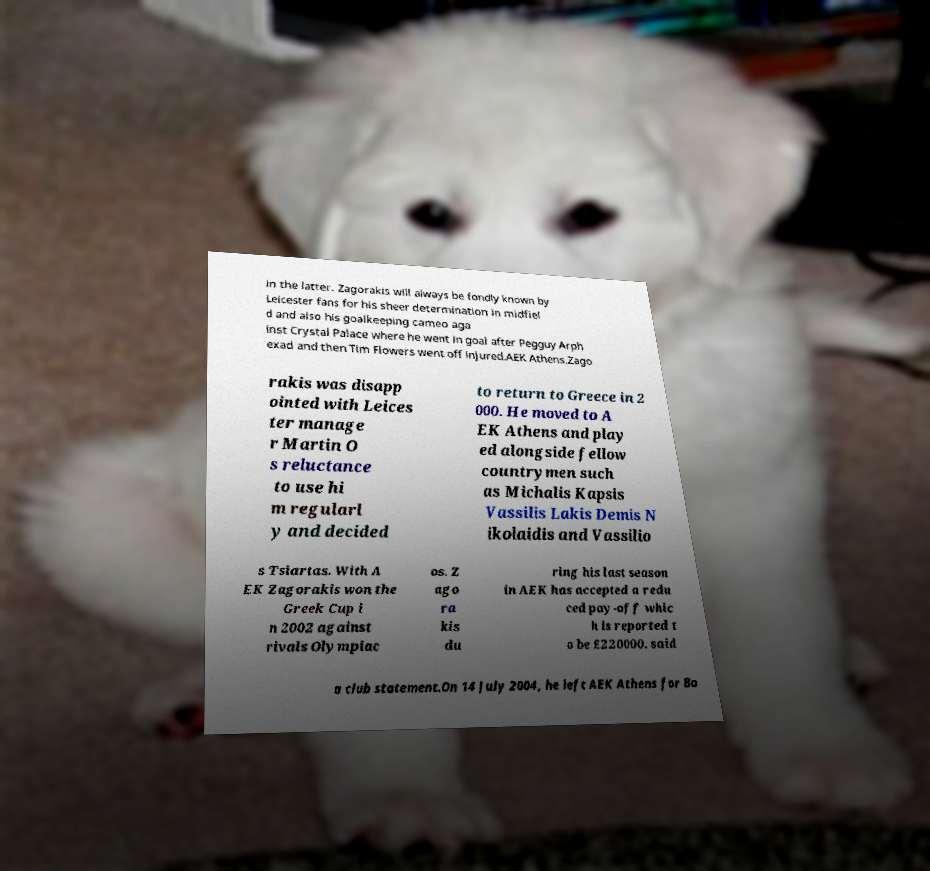Could you extract and type out the text from this image? in the latter. Zagorakis will always be fondly known by Leicester fans for his sheer determination in midfiel d and also his goalkeeping cameo aga inst Crystal Palace where he went in goal after Pegguy Arph exad and then Tim Flowers went off injured.AEK Athens.Zago rakis was disapp ointed with Leices ter manage r Martin O s reluctance to use hi m regularl y and decided to return to Greece in 2 000. He moved to A EK Athens and play ed alongside fellow countrymen such as Michalis Kapsis Vassilis Lakis Demis N ikolaidis and Vassilio s Tsiartas. With A EK Zagorakis won the Greek Cup i n 2002 against rivals Olympiac os. Z ago ra kis du ring his last season in AEK has accepted a redu ced pay-off whic h is reported t o be £220000. said a club statement.On 14 July 2004, he left AEK Athens for Bo 